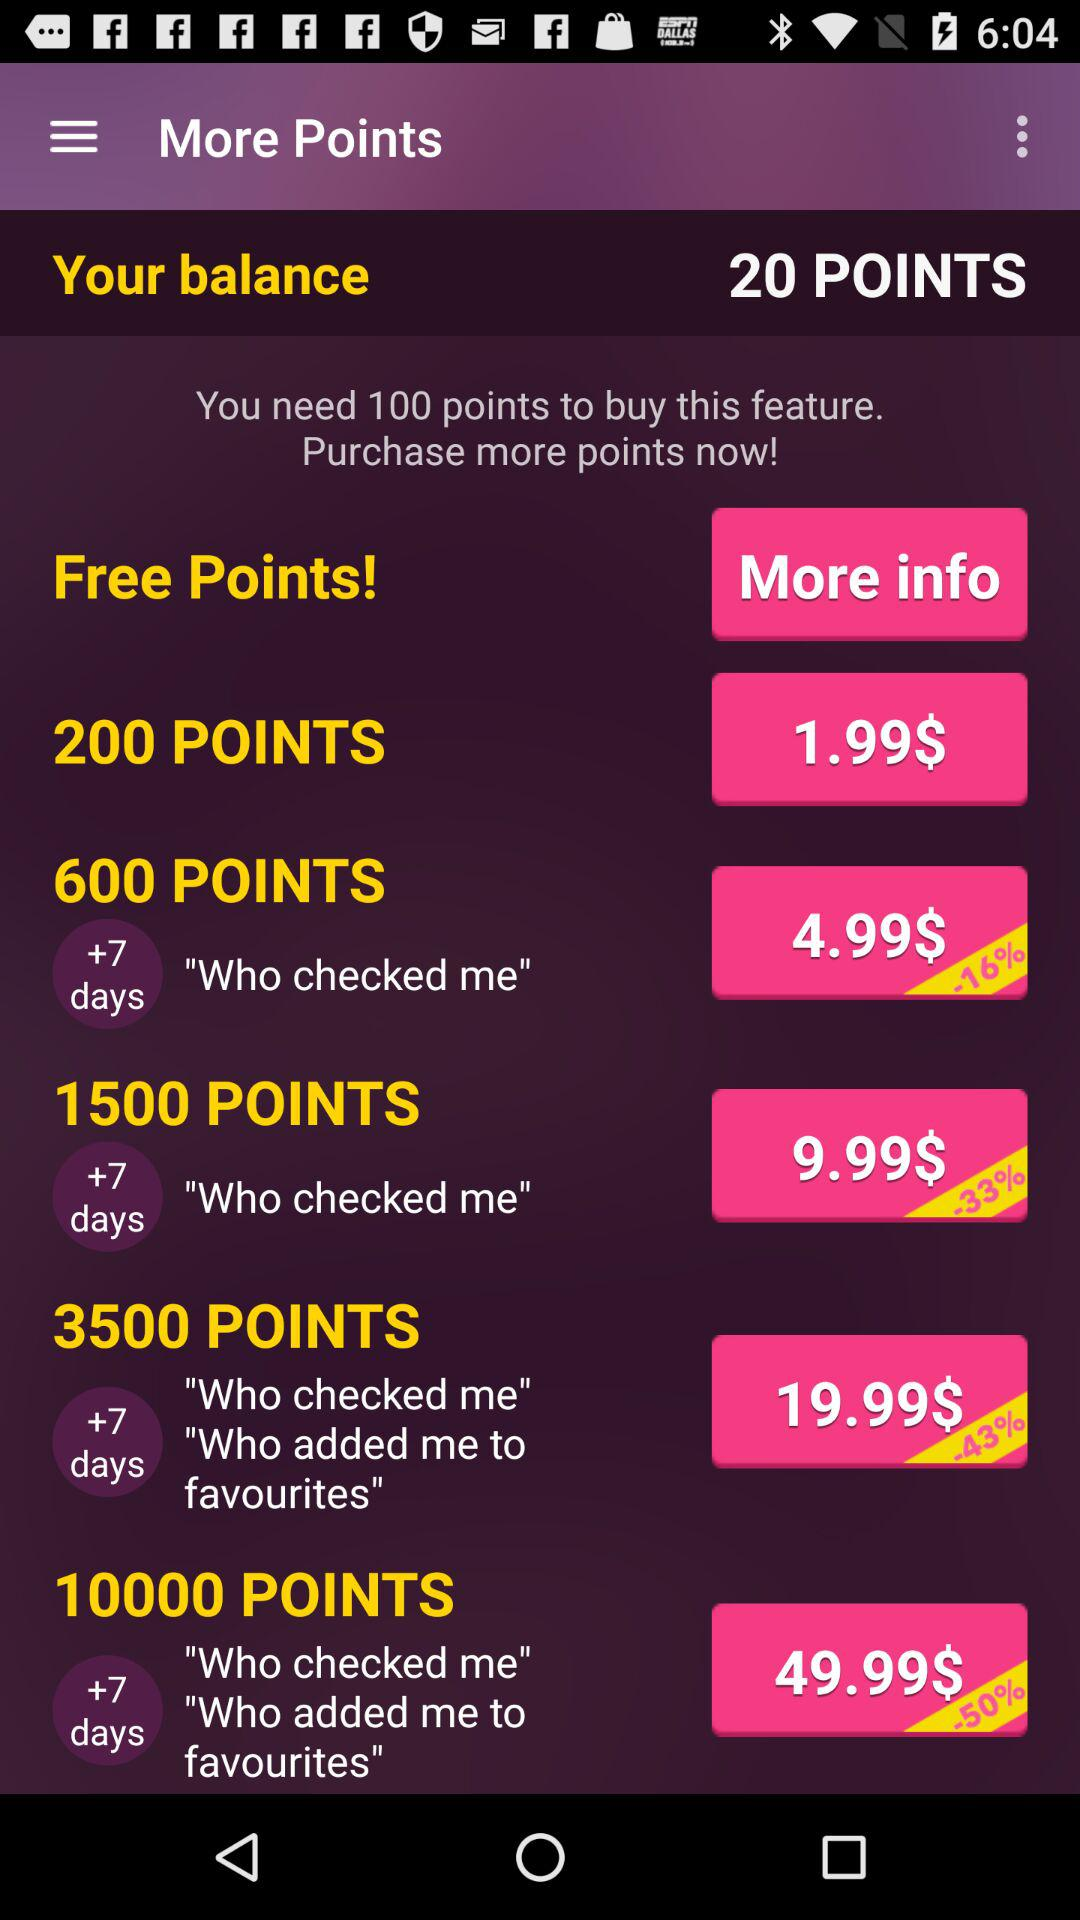What is the amount for 200 points? The amount is $1.99. 